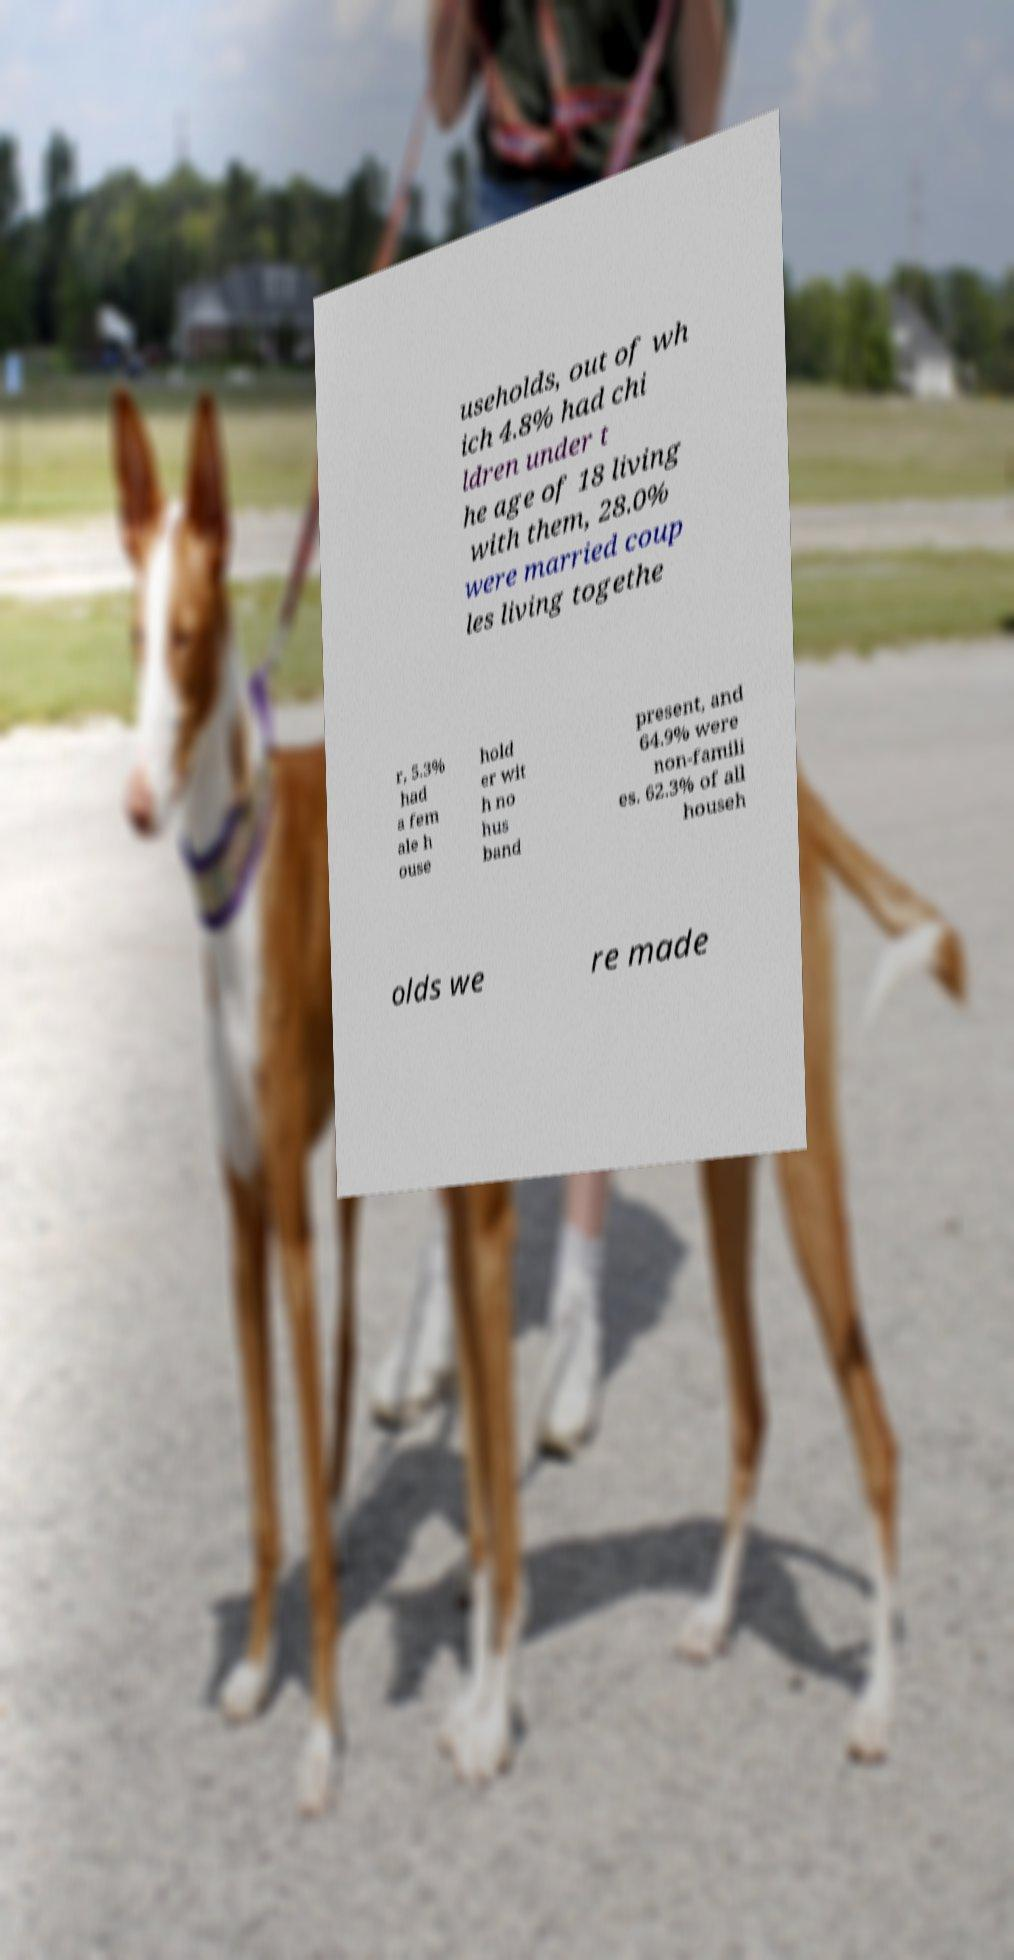I need the written content from this picture converted into text. Can you do that? useholds, out of wh ich 4.8% had chi ldren under t he age of 18 living with them, 28.0% were married coup les living togethe r, 5.3% had a fem ale h ouse hold er wit h no hus band present, and 64.9% were non-famili es. 62.3% of all househ olds we re made 